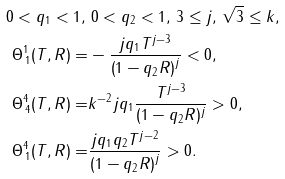Convert formula to latex. <formula><loc_0><loc_0><loc_500><loc_500>0 < q _ { 1 } < 1 , \, & \, 0 < q _ { 2 } < 1 , \, 3 \leq j , \, \sqrt { 3 } \leq k , \\ \Theta ^ { 1 } _ { \, 1 } ( T , R ) = & - \frac { j q _ { 1 } T ^ { j - 3 } } { \left ( 1 - q _ { 2 } R \right ) ^ { j } } < 0 , \\ \Theta ^ { 4 } _ { \, 4 } ( T , R ) = & k ^ { - 2 } j q _ { 1 } \frac { T ^ { j - 3 } } { ( 1 - q _ { 2 } R ) ^ { j } } > 0 , \\ \Theta ^ { 4 } _ { \, 1 } ( T , R ) = & \frac { j q _ { 1 } q _ { 2 } T ^ { j - 2 } } { \left ( 1 - q _ { 2 } R \right ) ^ { j } } > 0 .</formula> 